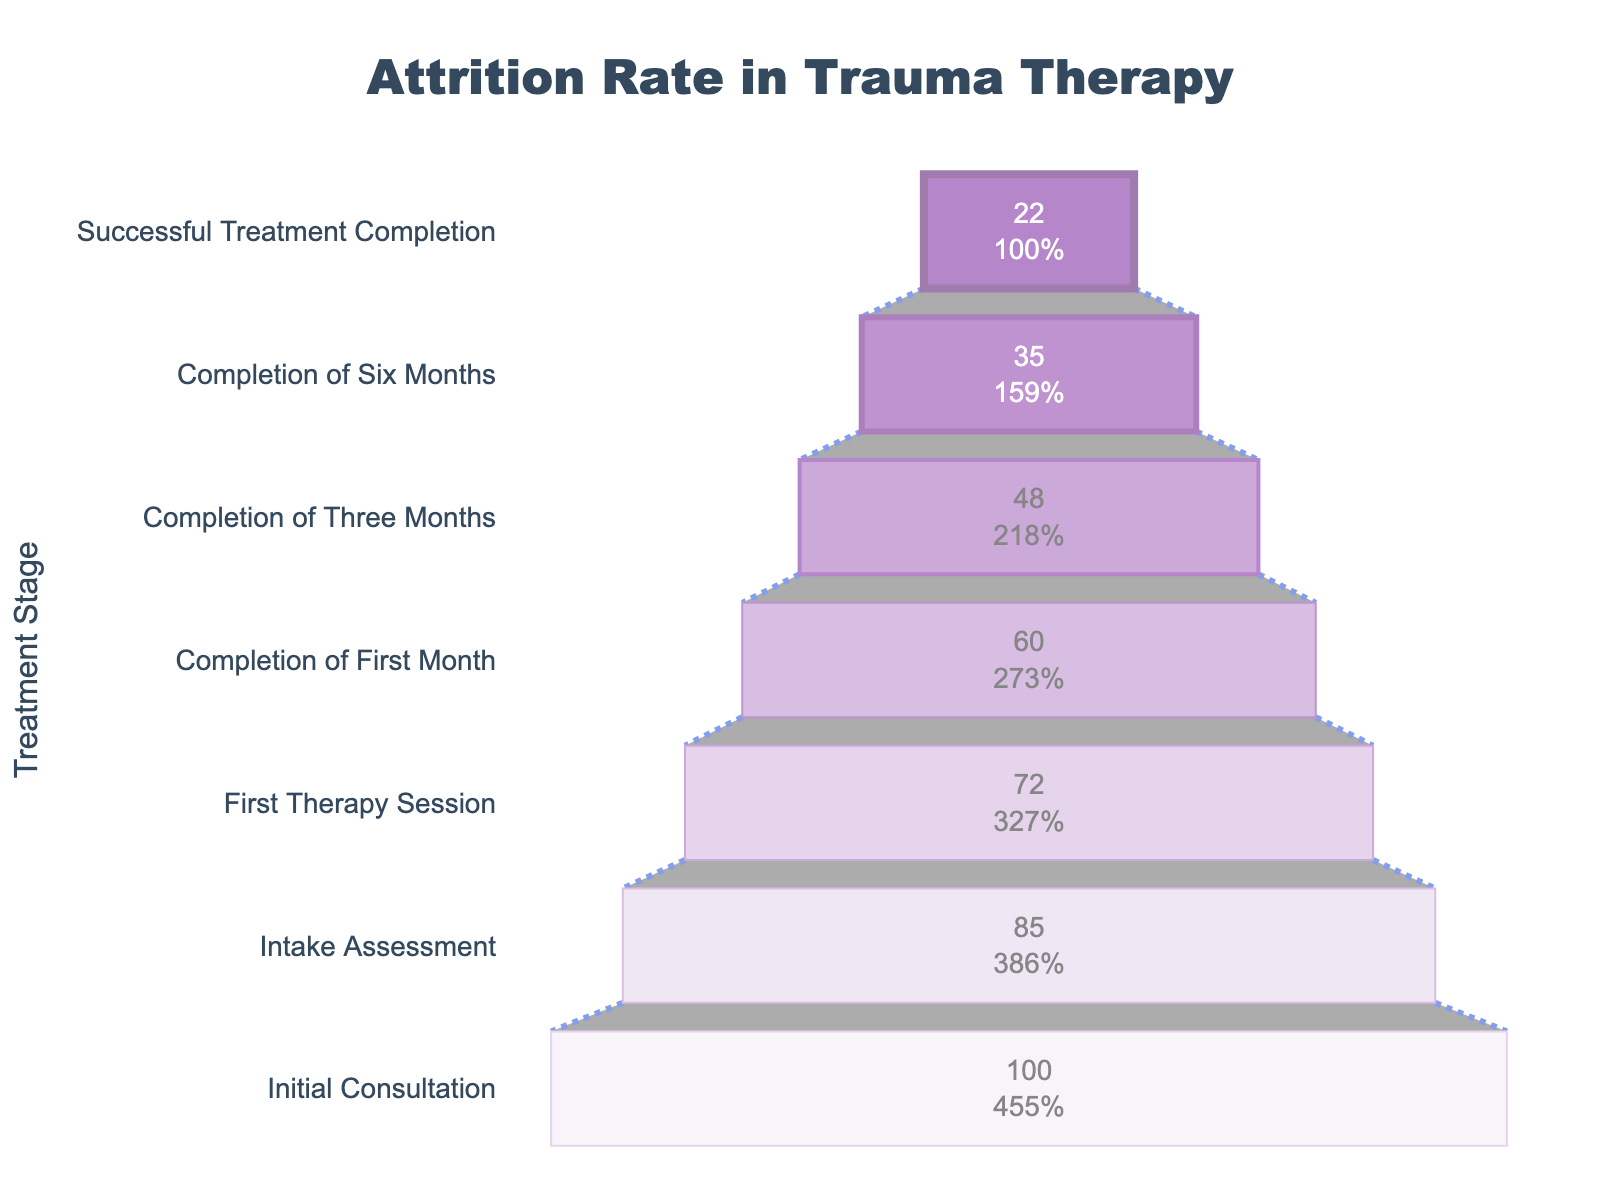What is the title of the funnel chart? The title of the funnel chart is located at the top center of the figure. It reads "Attrition Rate in Trauma Therapy”. By reading this title, we understand that the chart is about the percentage of patients who remain in therapy at each stage of the treatment process.
Answer: Attrition Rate in Trauma Therapy Which stage has the highest percentage of patients? The highest percentage is at the “Initial Consultation” stage, where it is 100%. This is visually evident because the funnel chart starts at 100% for this stage, representing that all patients initially consult.
Answer: Initial Consultation How many stages are there in the funnel chart? By counting the distinct labels on the y-axis from top to bottom, we can determine there are 7 stages in the funnel chart.
Answer: 7 What is the percentage of patients that complete six months of therapy? By reading the value indicated for the "Completion of Six Months" stage on the x-axis, we notice it is 35%.
Answer: 35% How much does the patient retention drop from the Initial Consultation to the Successful Treatment Completion stage? The difference in retention between the Initial Consultation (100%) and Successful Treatment Completion (22%) can be found by subtracting 22 from 100. This yields a drop of 78%.
Answer: 78% How many stages have a retention rate above 50%? The stages with retention percentages greater than 50% are “Initial Consultation” (100%), “Intake Assessment” (85%), and “First Therapy Session” (72%). This sums to three stages.
Answer: 3 Which stage shows the largest single drop in patient retention? The largest single drop in patient retention can be found by identifying the biggest difference in percentages between consecutive stages. The largest drop is between “Completion of Six Months” (35%) and “Successful Treatment Completion” (22%), which is a drop of 13%.
Answer: Completion of Six Months to Successful Treatment Completion What percentage of patients complete the first month of therapy? Looking at the "Completion of First Month" stage, we see the corresponding percentage is 60%.
Answer: 60% Is the percentage of patients completing three months of therapy greater than half of those at the Initial Consultation? Half of the Initial Consultation is 50% (0.5 * 100%). The "Completion of Three Months" stage is at 48%, which is less than half.
Answer: No, it is less What is the average retention rate across all stages? To find the average, add all percentages and divide by the number of stages: (100 + 85 + 72 + 60 + 48 + 35 + 22) / 7 = 60.29%.
Answer: 60.29% 